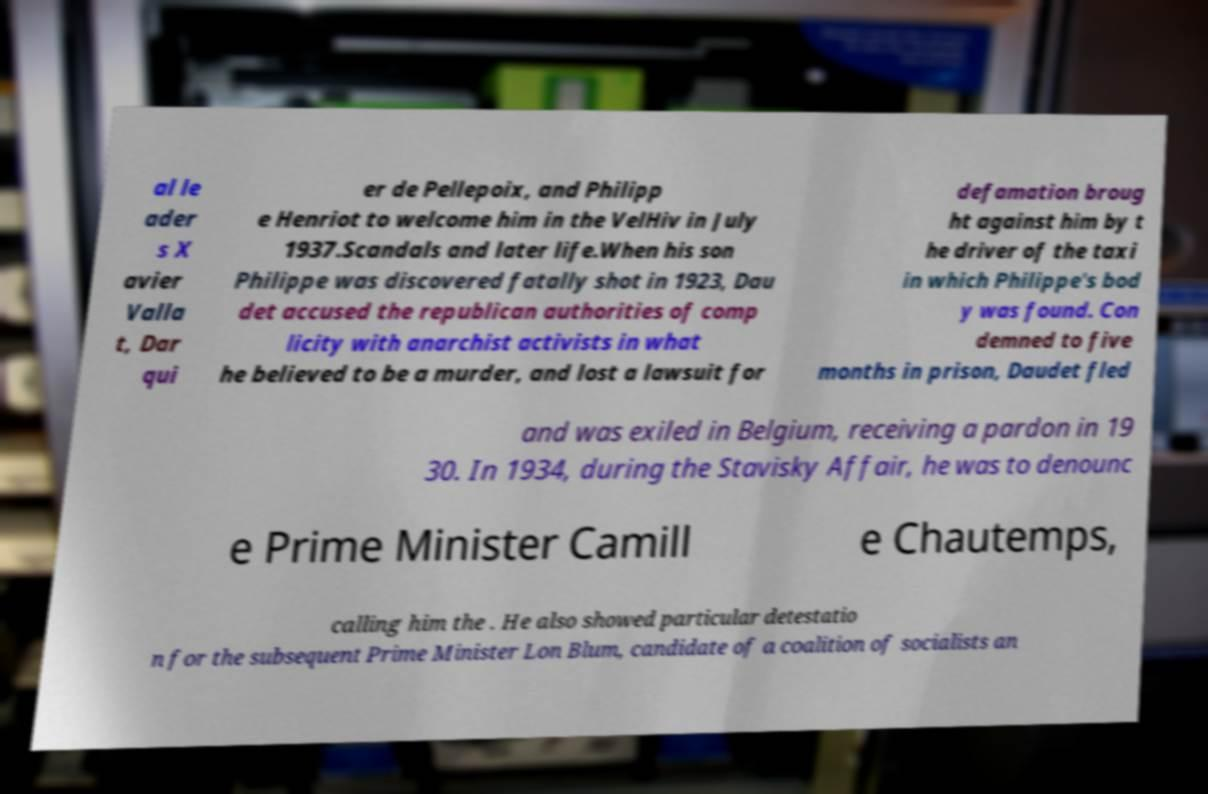Could you assist in decoding the text presented in this image and type it out clearly? al le ader s X avier Valla t, Dar qui er de Pellepoix, and Philipp e Henriot to welcome him in the VelHiv in July 1937.Scandals and later life.When his son Philippe was discovered fatally shot in 1923, Dau det accused the republican authorities of comp licity with anarchist activists in what he believed to be a murder, and lost a lawsuit for defamation broug ht against him by t he driver of the taxi in which Philippe's bod y was found. Con demned to five months in prison, Daudet fled and was exiled in Belgium, receiving a pardon in 19 30. In 1934, during the Stavisky Affair, he was to denounc e Prime Minister Camill e Chautemps, calling him the . He also showed particular detestatio n for the subsequent Prime Minister Lon Blum, candidate of a coalition of socialists an 